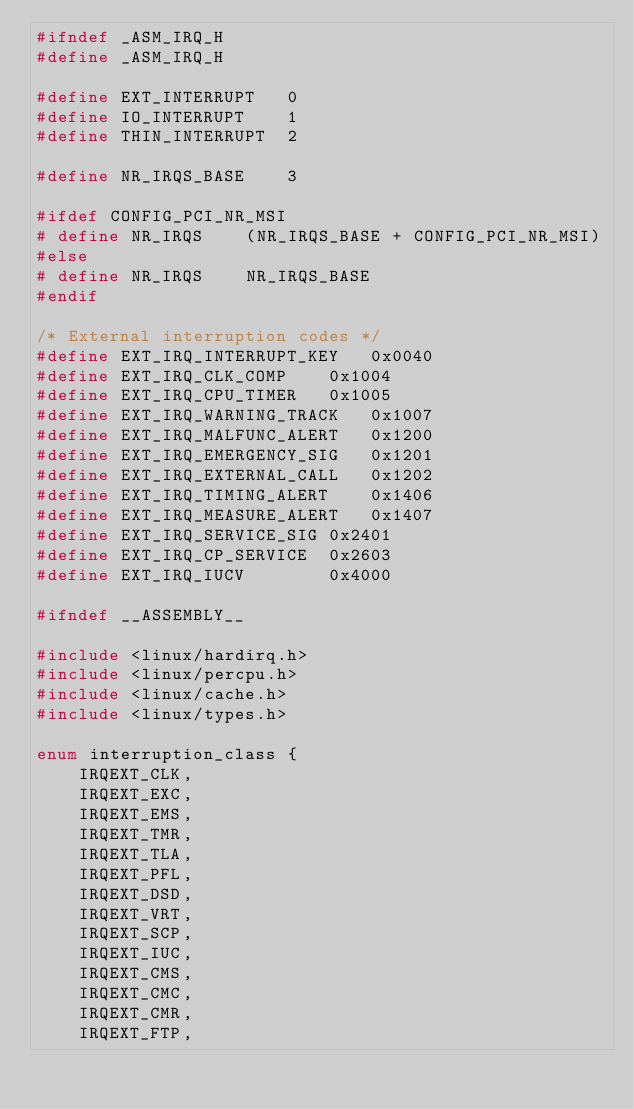Convert code to text. <code><loc_0><loc_0><loc_500><loc_500><_C_>#ifndef _ASM_IRQ_H
#define _ASM_IRQ_H

#define EXT_INTERRUPT	0
#define IO_INTERRUPT	1
#define THIN_INTERRUPT	2

#define NR_IRQS_BASE	3

#ifdef CONFIG_PCI_NR_MSI
# define NR_IRQS	(NR_IRQS_BASE + CONFIG_PCI_NR_MSI)
#else
# define NR_IRQS	NR_IRQS_BASE
#endif

/* External interruption codes */
#define EXT_IRQ_INTERRUPT_KEY	0x0040
#define EXT_IRQ_CLK_COMP	0x1004
#define EXT_IRQ_CPU_TIMER	0x1005
#define EXT_IRQ_WARNING_TRACK	0x1007
#define EXT_IRQ_MALFUNC_ALERT	0x1200
#define EXT_IRQ_EMERGENCY_SIG	0x1201
#define EXT_IRQ_EXTERNAL_CALL	0x1202
#define EXT_IRQ_TIMING_ALERT	0x1406
#define EXT_IRQ_MEASURE_ALERT	0x1407
#define EXT_IRQ_SERVICE_SIG	0x2401
#define EXT_IRQ_CP_SERVICE	0x2603
#define EXT_IRQ_IUCV		0x4000

#ifndef __ASSEMBLY__

#include <linux/hardirq.h>
#include <linux/percpu.h>
#include <linux/cache.h>
#include <linux/types.h>

enum interruption_class {
	IRQEXT_CLK,
	IRQEXT_EXC,
	IRQEXT_EMS,
	IRQEXT_TMR,
	IRQEXT_TLA,
	IRQEXT_PFL,
	IRQEXT_DSD,
	IRQEXT_VRT,
	IRQEXT_SCP,
	IRQEXT_IUC,
	IRQEXT_CMS,
	IRQEXT_CMC,
	IRQEXT_CMR,
	IRQEXT_FTP,</code> 